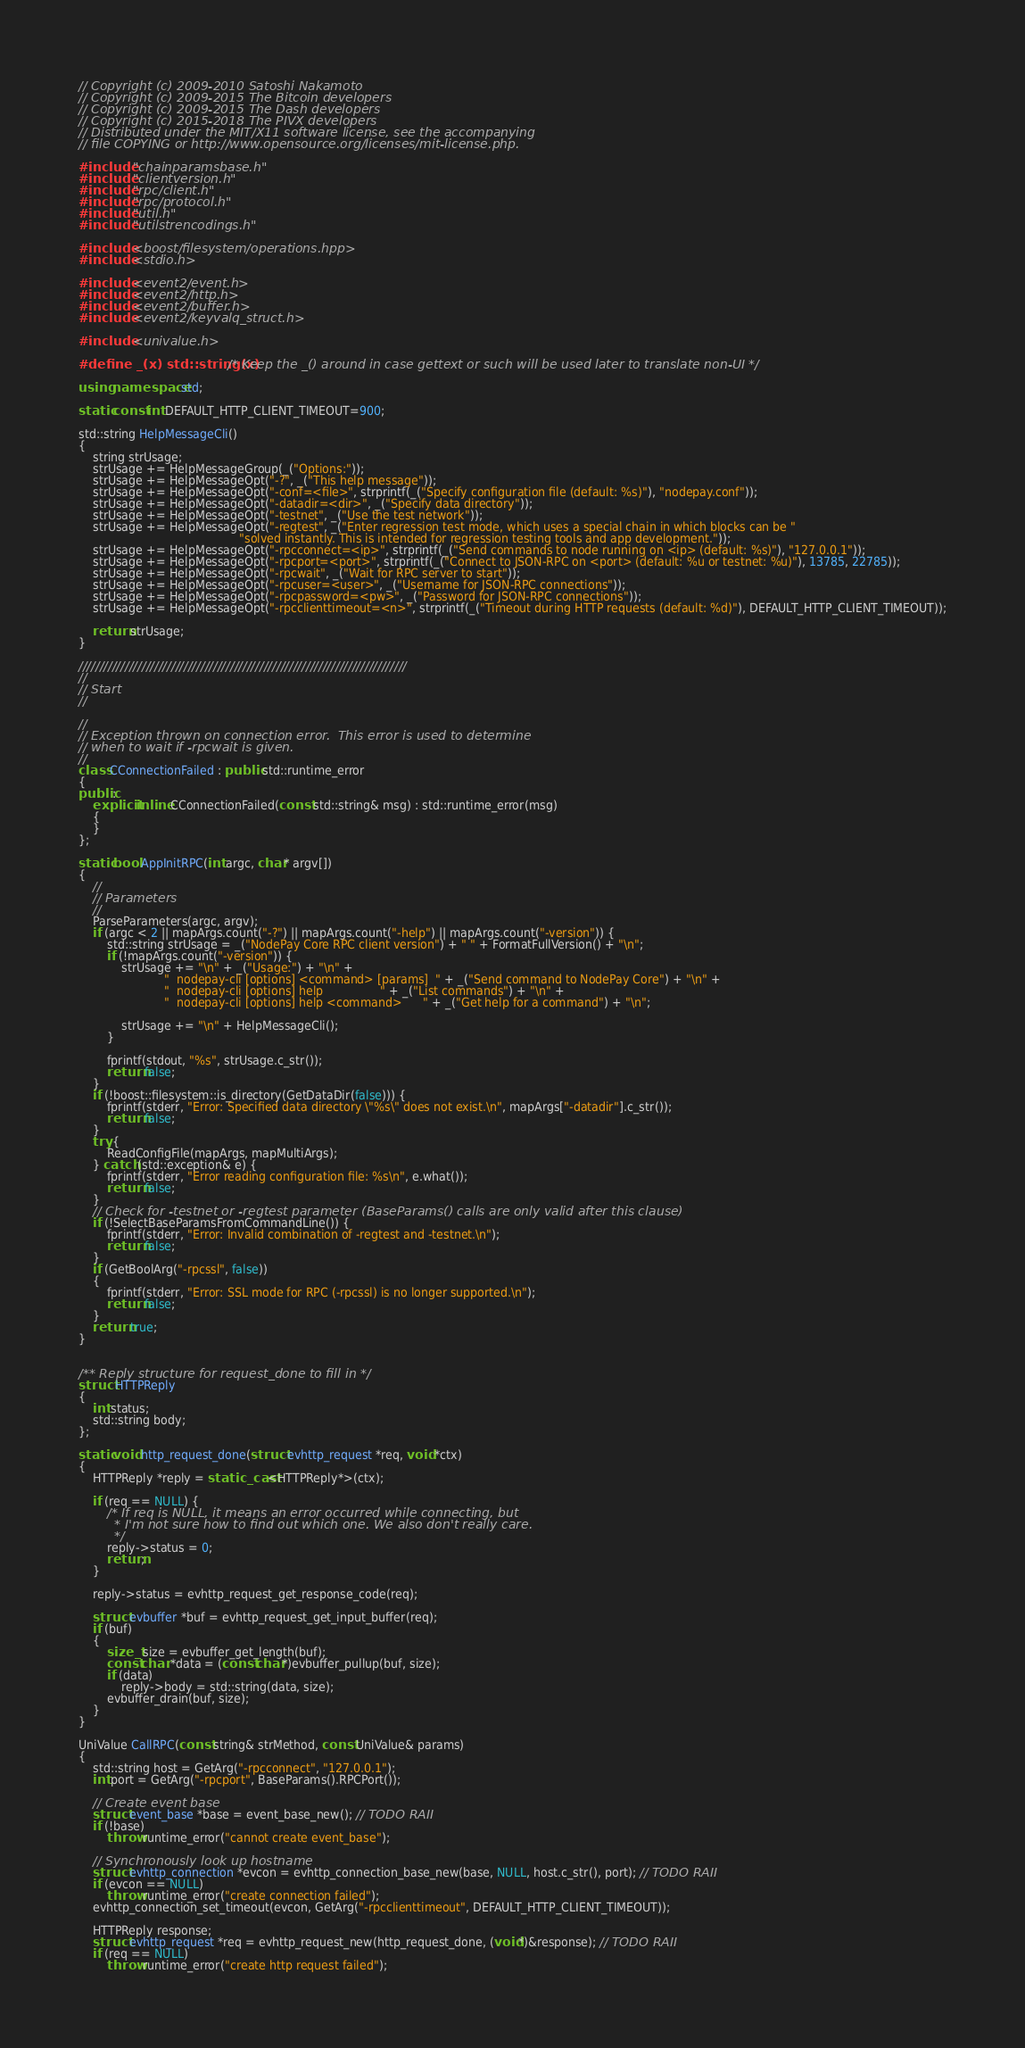Convert code to text. <code><loc_0><loc_0><loc_500><loc_500><_C++_>// Copyright (c) 2009-2010 Satoshi Nakamoto
// Copyright (c) 2009-2015 The Bitcoin developers
// Copyright (c) 2009-2015 The Dash developers
// Copyright (c) 2015-2018 The PIVX developers
// Distributed under the MIT/X11 software license, see the accompanying
// file COPYING or http://www.opensource.org/licenses/mit-license.php.

#include "chainparamsbase.h"
#include "clientversion.h"
#include "rpc/client.h"
#include "rpc/protocol.h"
#include "util.h"
#include "utilstrencodings.h"

#include <boost/filesystem/operations.hpp>
#include <stdio.h>

#include <event2/event.h>
#include <event2/http.h>
#include <event2/buffer.h>
#include <event2/keyvalq_struct.h>

#include <univalue.h>

#define _(x) std::string(x) /* Keep the _() around in case gettext or such will be used later to translate non-UI */

using namespace std;

static const int DEFAULT_HTTP_CLIENT_TIMEOUT=900;

std::string HelpMessageCli()
{
    string strUsage;
    strUsage += HelpMessageGroup(_("Options:"));
    strUsage += HelpMessageOpt("-?", _("This help message"));
    strUsage += HelpMessageOpt("-conf=<file>", strprintf(_("Specify configuration file (default: %s)"), "nodepay.conf"));
    strUsage += HelpMessageOpt("-datadir=<dir>", _("Specify data directory"));
    strUsage += HelpMessageOpt("-testnet", _("Use the test network"));
    strUsage += HelpMessageOpt("-regtest", _("Enter regression test mode, which uses a special chain in which blocks can be "
                                             "solved instantly. This is intended for regression testing tools and app development."));
    strUsage += HelpMessageOpt("-rpcconnect=<ip>", strprintf(_("Send commands to node running on <ip> (default: %s)"), "127.0.0.1"));
    strUsage += HelpMessageOpt("-rpcport=<port>", strprintf(_("Connect to JSON-RPC on <port> (default: %u or testnet: %u)"), 13785, 22785));
    strUsage += HelpMessageOpt("-rpcwait", _("Wait for RPC server to start"));
    strUsage += HelpMessageOpt("-rpcuser=<user>", _("Username for JSON-RPC connections"));
    strUsage += HelpMessageOpt("-rpcpassword=<pw>", _("Password for JSON-RPC connections"));
    strUsage += HelpMessageOpt("-rpcclienttimeout=<n>", strprintf(_("Timeout during HTTP requests (default: %d)"), DEFAULT_HTTP_CLIENT_TIMEOUT));

    return strUsage;
}

//////////////////////////////////////////////////////////////////////////////
//
// Start
//

//
// Exception thrown on connection error.  This error is used to determine
// when to wait if -rpcwait is given.
//
class CConnectionFailed : public std::runtime_error
{
public:
    explicit inline CConnectionFailed(const std::string& msg) : std::runtime_error(msg)
    {
    }
};

static bool AppInitRPC(int argc, char* argv[])
{
    //
    // Parameters
    //
    ParseParameters(argc, argv);
    if (argc < 2 || mapArgs.count("-?") || mapArgs.count("-help") || mapArgs.count("-version")) {
        std::string strUsage = _("NodePay Core RPC client version") + " " + FormatFullVersion() + "\n";
        if (!mapArgs.count("-version")) {
            strUsage += "\n" + _("Usage:") + "\n" +
                        "  nodepay-cli [options] <command> [params]  " + _("Send command to NodePay Core") + "\n" +
                        "  nodepay-cli [options] help                " + _("List commands") + "\n" +
                        "  nodepay-cli [options] help <command>      " + _("Get help for a command") + "\n";

            strUsage += "\n" + HelpMessageCli();
        }

        fprintf(stdout, "%s", strUsage.c_str());
        return false;
    }
    if (!boost::filesystem::is_directory(GetDataDir(false))) {
        fprintf(stderr, "Error: Specified data directory \"%s\" does not exist.\n", mapArgs["-datadir"].c_str());
        return false;
    }
    try {
        ReadConfigFile(mapArgs, mapMultiArgs);
    } catch (std::exception& e) {
        fprintf(stderr, "Error reading configuration file: %s\n", e.what());
        return false;
    }
    // Check for -testnet or -regtest parameter (BaseParams() calls are only valid after this clause)
    if (!SelectBaseParamsFromCommandLine()) {
        fprintf(stderr, "Error: Invalid combination of -regtest and -testnet.\n");
        return false;
    }
    if (GetBoolArg("-rpcssl", false))
    {
        fprintf(stderr, "Error: SSL mode for RPC (-rpcssl) is no longer supported.\n");
        return false;
    }
    return true;
}


/** Reply structure for request_done to fill in */
struct HTTPReply
{
    int status;
    std::string body;
};

static void http_request_done(struct evhttp_request *req, void *ctx)
{
    HTTPReply *reply = static_cast<HTTPReply*>(ctx);

    if (req == NULL) {
        /* If req is NULL, it means an error occurred while connecting, but
         * I'm not sure how to find out which one. We also don't really care.
         */
        reply->status = 0;
        return;
    }

    reply->status = evhttp_request_get_response_code(req);

    struct evbuffer *buf = evhttp_request_get_input_buffer(req);
    if (buf)
    {
        size_t size = evbuffer_get_length(buf);
        const char *data = (const char*)evbuffer_pullup(buf, size);
        if (data)
            reply->body = std::string(data, size);
        evbuffer_drain(buf, size);
    }
}

UniValue CallRPC(const string& strMethod, const UniValue& params)
{
    std::string host = GetArg("-rpcconnect", "127.0.0.1");
    int port = GetArg("-rpcport", BaseParams().RPCPort());

    // Create event base
    struct event_base *base = event_base_new(); // TODO RAII
    if (!base)
        throw runtime_error("cannot create event_base");

    // Synchronously look up hostname
    struct evhttp_connection *evcon = evhttp_connection_base_new(base, NULL, host.c_str(), port); // TODO RAII
    if (evcon == NULL)
        throw runtime_error("create connection failed");
    evhttp_connection_set_timeout(evcon, GetArg("-rpcclienttimeout", DEFAULT_HTTP_CLIENT_TIMEOUT));

    HTTPReply response;
    struct evhttp_request *req = evhttp_request_new(http_request_done, (void*)&response); // TODO RAII
    if (req == NULL)
        throw runtime_error("create http request failed");
</code> 